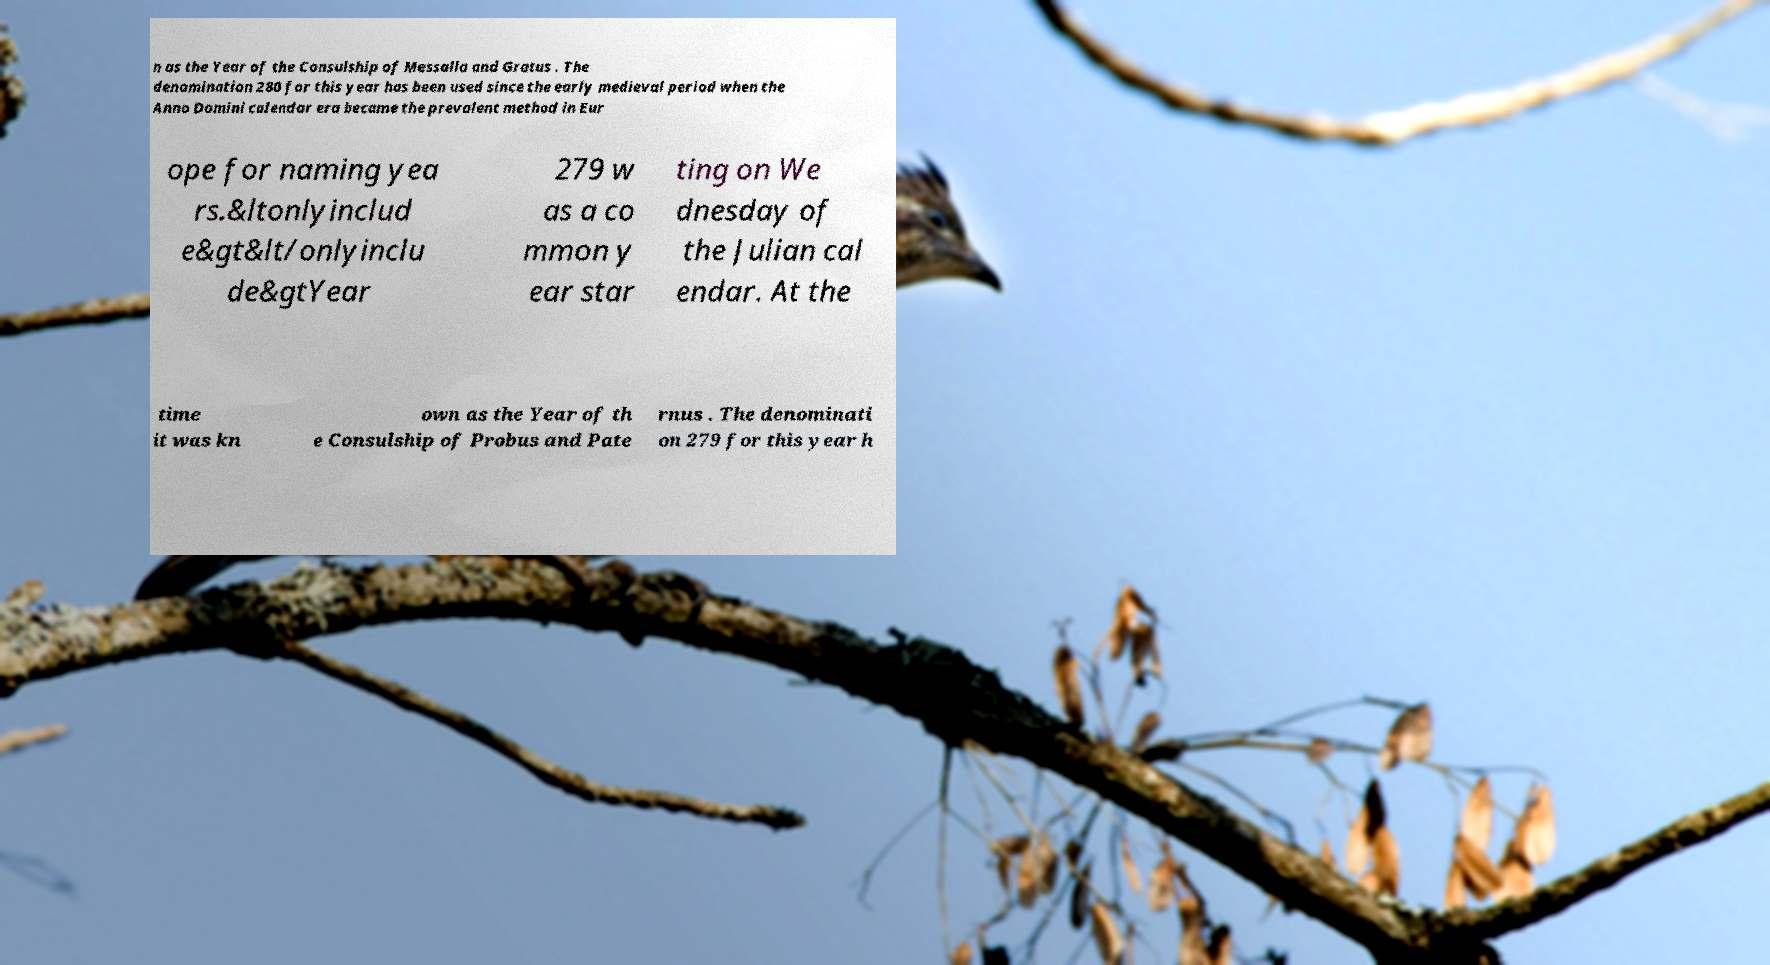Could you assist in decoding the text presented in this image and type it out clearly? n as the Year of the Consulship of Messalla and Gratus . The denomination 280 for this year has been used since the early medieval period when the Anno Domini calendar era became the prevalent method in Eur ope for naming yea rs.&ltonlyinclud e&gt&lt/onlyinclu de&gtYear 279 w as a co mmon y ear star ting on We dnesday of the Julian cal endar. At the time it was kn own as the Year of th e Consulship of Probus and Pate rnus . The denominati on 279 for this year h 